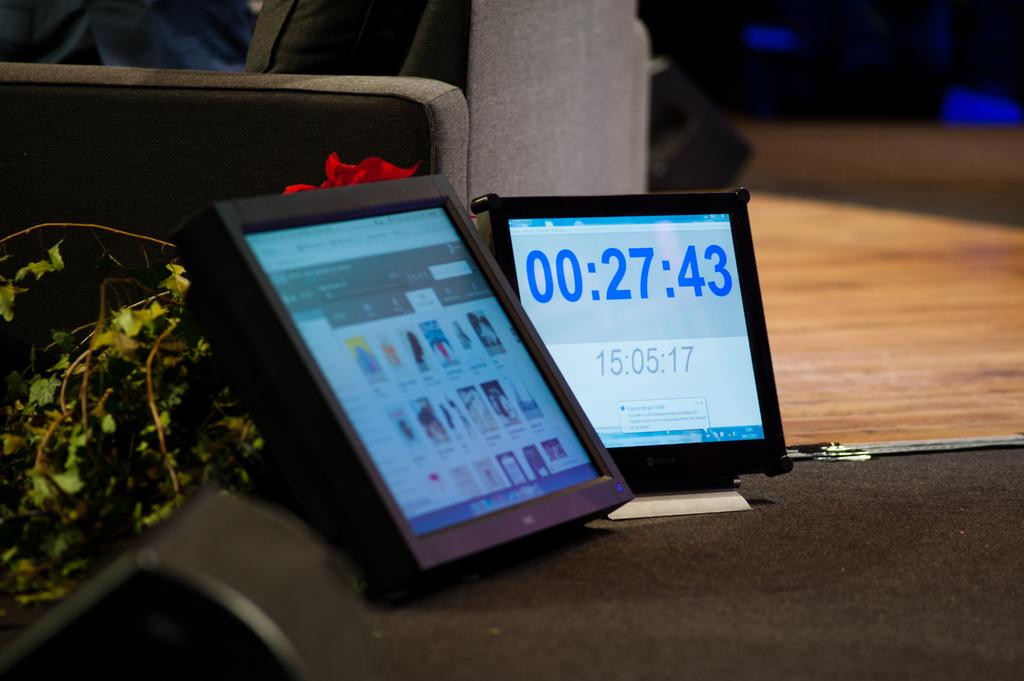How many display screens are present in the image? There are two display screens in the image. What can be seen on the display screens? The display screens have pictures and numbers on them. What is located on the table in the image? There is a speaker on the table. What type of vegetation is visible in the image? There is a plant visible in the image. What type of seating is present in the image? There is a sofa on the floor. Can you see a squirrel playing a game on the display screens in the image? There is no squirrel or game present on the display screens in the image; they have pictures and numbers on them. What part of the brain is visible in the image? There is no brain visible in the image. 